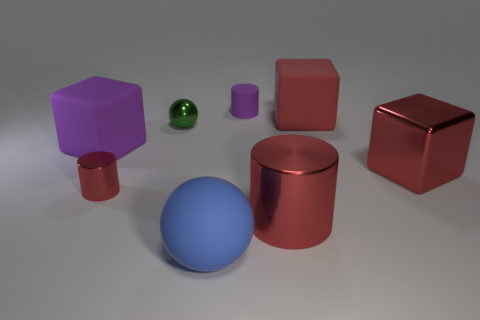How would you explain the perspective of this image? The perspective in this image is from a slightly elevated angle looking down onto the scene. This viewpoint allows the viewer to see the tops and sides of the objects, thereby helping to gauge their three-dimensional shapes and sizes. There is also a clear depth of field, with objects appearing softer and less in focus as they recede into the background, adding to the perception of three-dimensional space. 